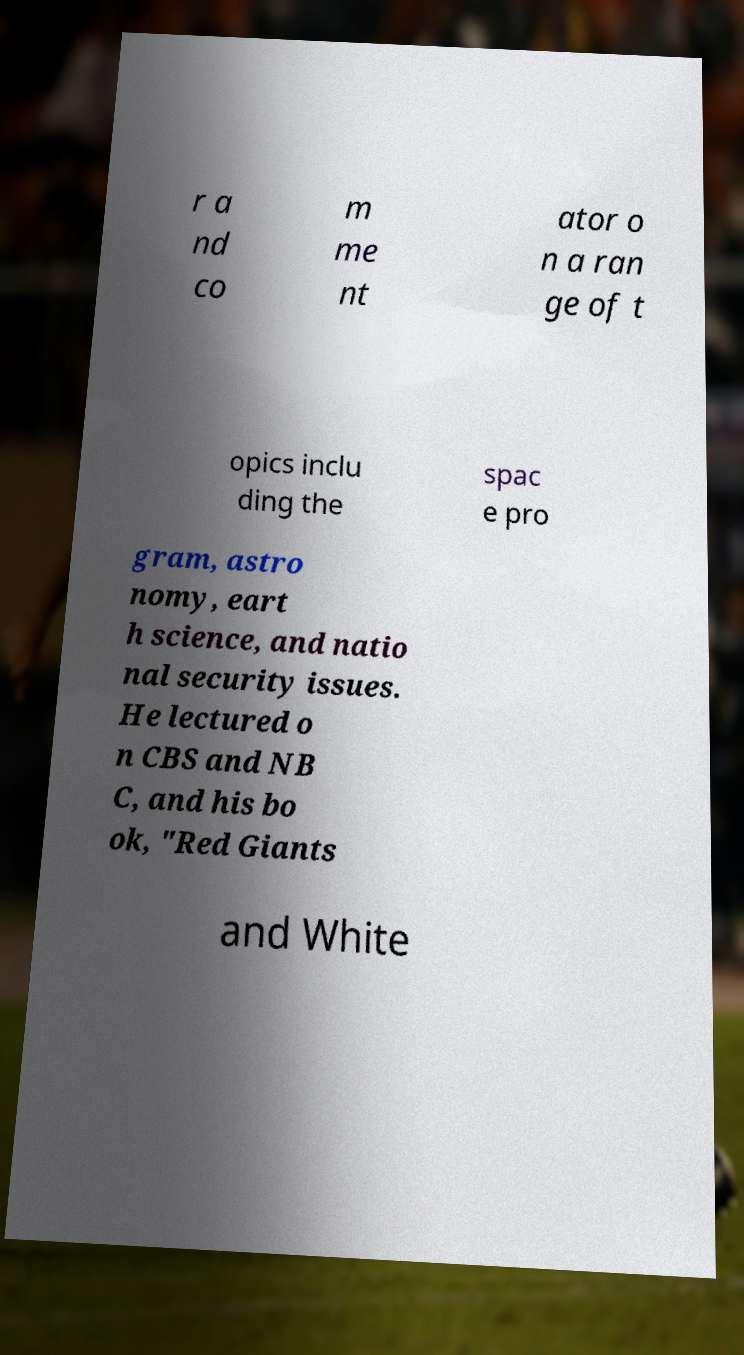Can you read and provide the text displayed in the image?This photo seems to have some interesting text. Can you extract and type it out for me? r a nd co m me nt ator o n a ran ge of t opics inclu ding the spac e pro gram, astro nomy, eart h science, and natio nal security issues. He lectured o n CBS and NB C, and his bo ok, "Red Giants and White 